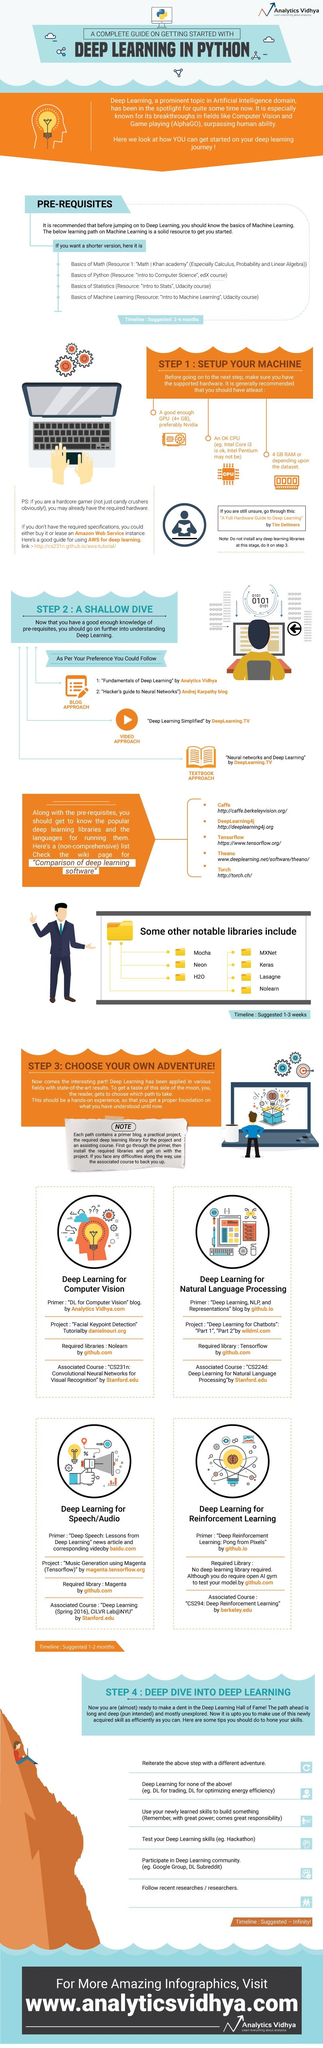Give some essential details in this illustration. Nvidia is the recommended GPU for machine setup. The learning path to Machine Learning includes Python as the subject listed second. The video 'Deep Learning Simplified...' has been recommended as a helpful resource for understanding deep learning. The library "Nolearn" is required for deep learning applications in the field of computer vision. The fourth popular deep learning library is Theano. 